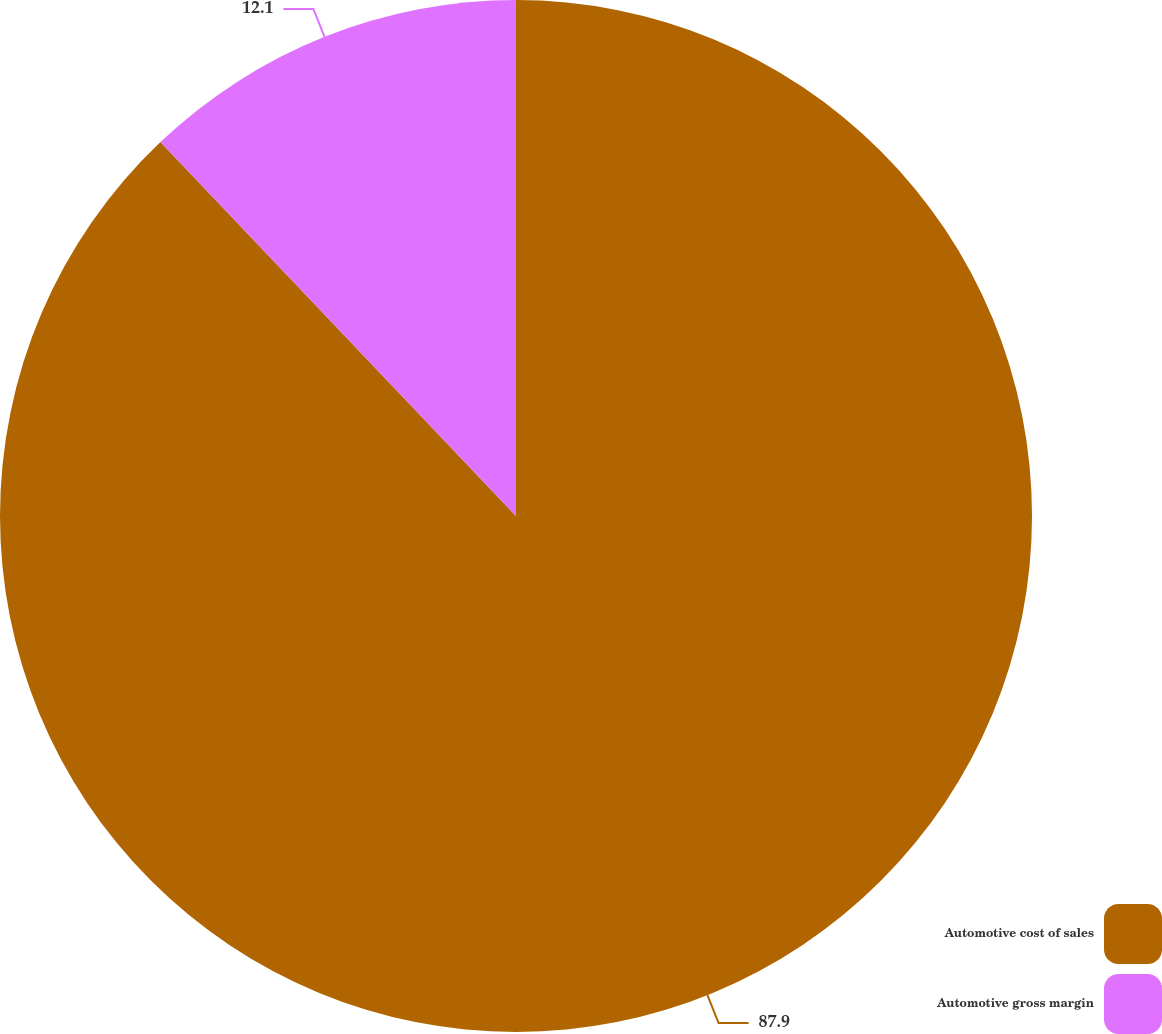Convert chart to OTSL. <chart><loc_0><loc_0><loc_500><loc_500><pie_chart><fcel>Automotive cost of sales<fcel>Automotive gross margin<nl><fcel>87.9%<fcel>12.1%<nl></chart> 